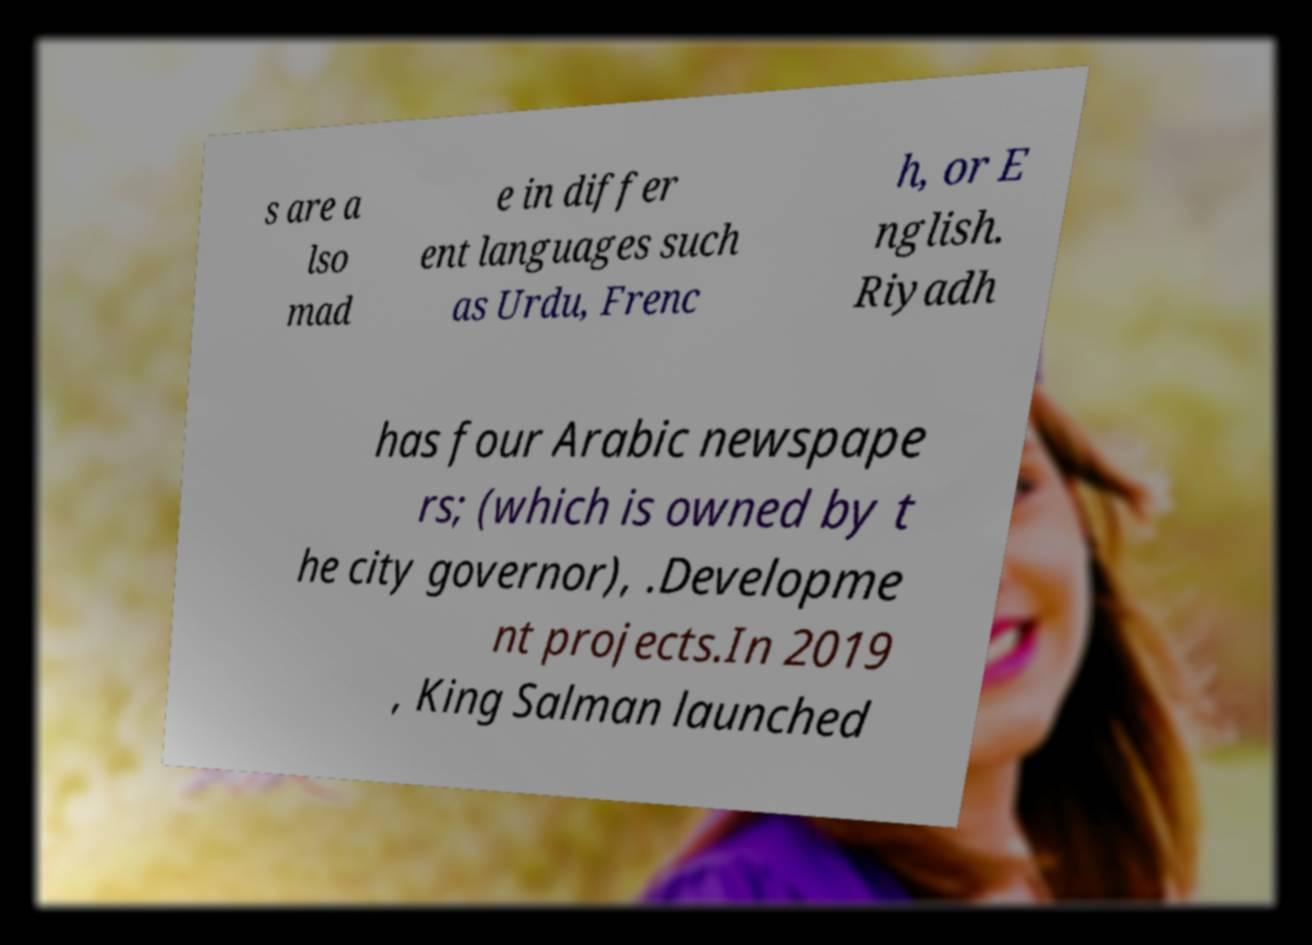Could you assist in decoding the text presented in this image and type it out clearly? s are a lso mad e in differ ent languages such as Urdu, Frenc h, or E nglish. Riyadh has four Arabic newspape rs; (which is owned by t he city governor), .Developme nt projects.In 2019 , King Salman launched 